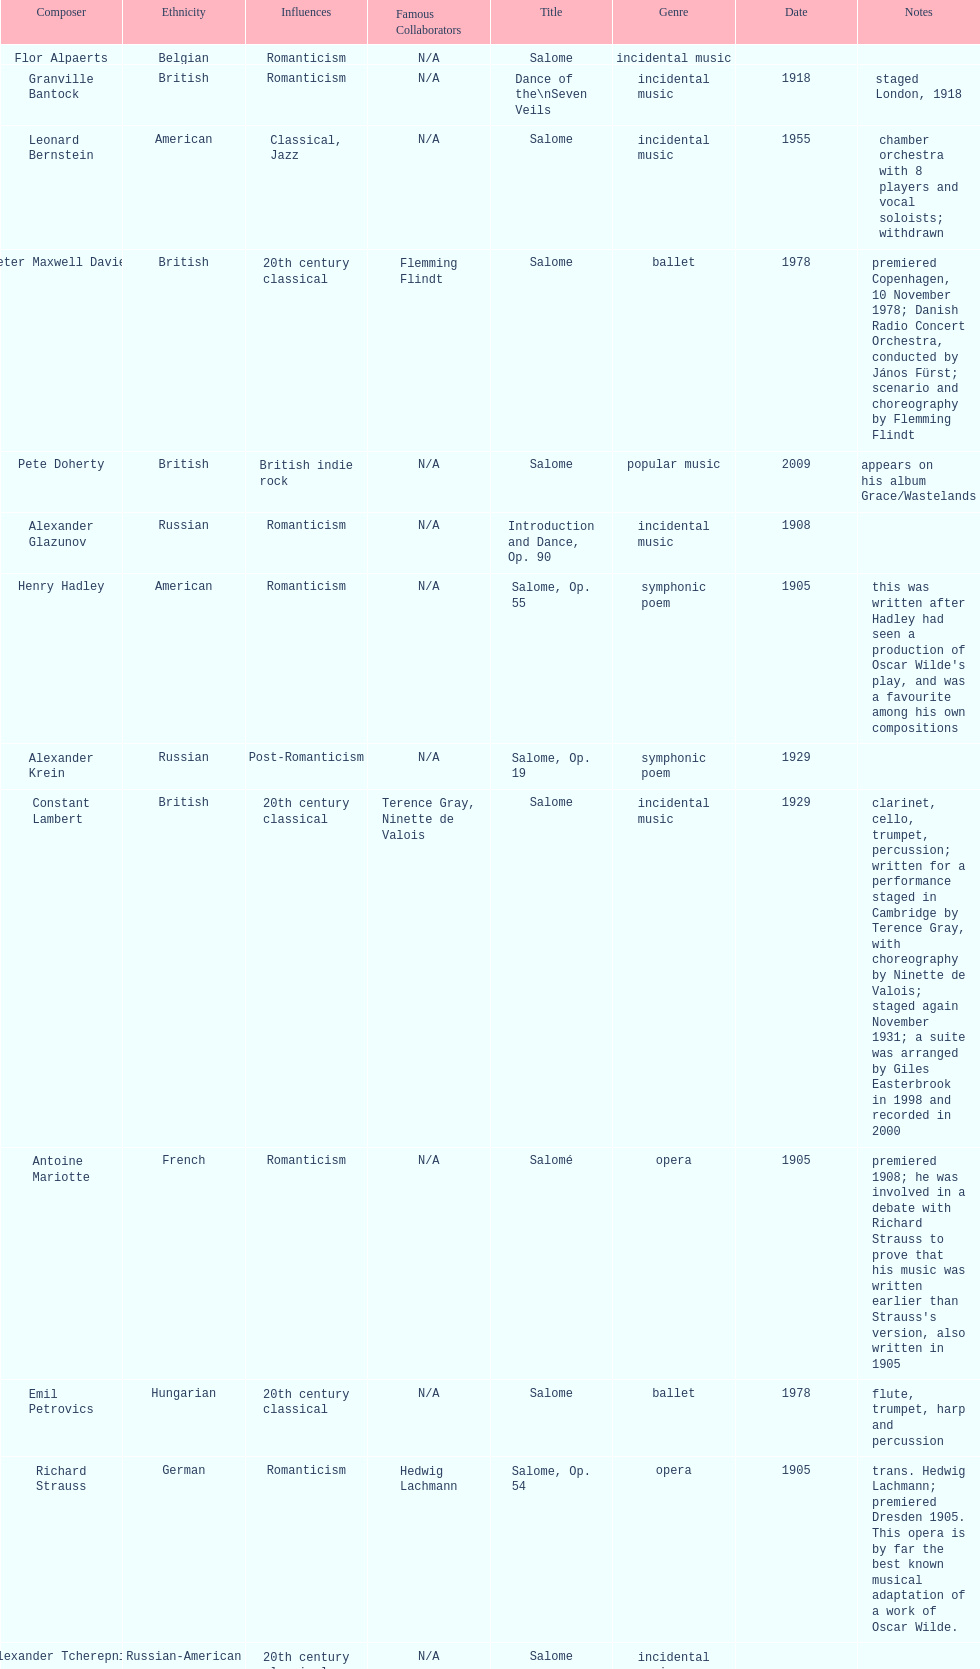Who is next on the list after alexander krein? Constant Lambert. 